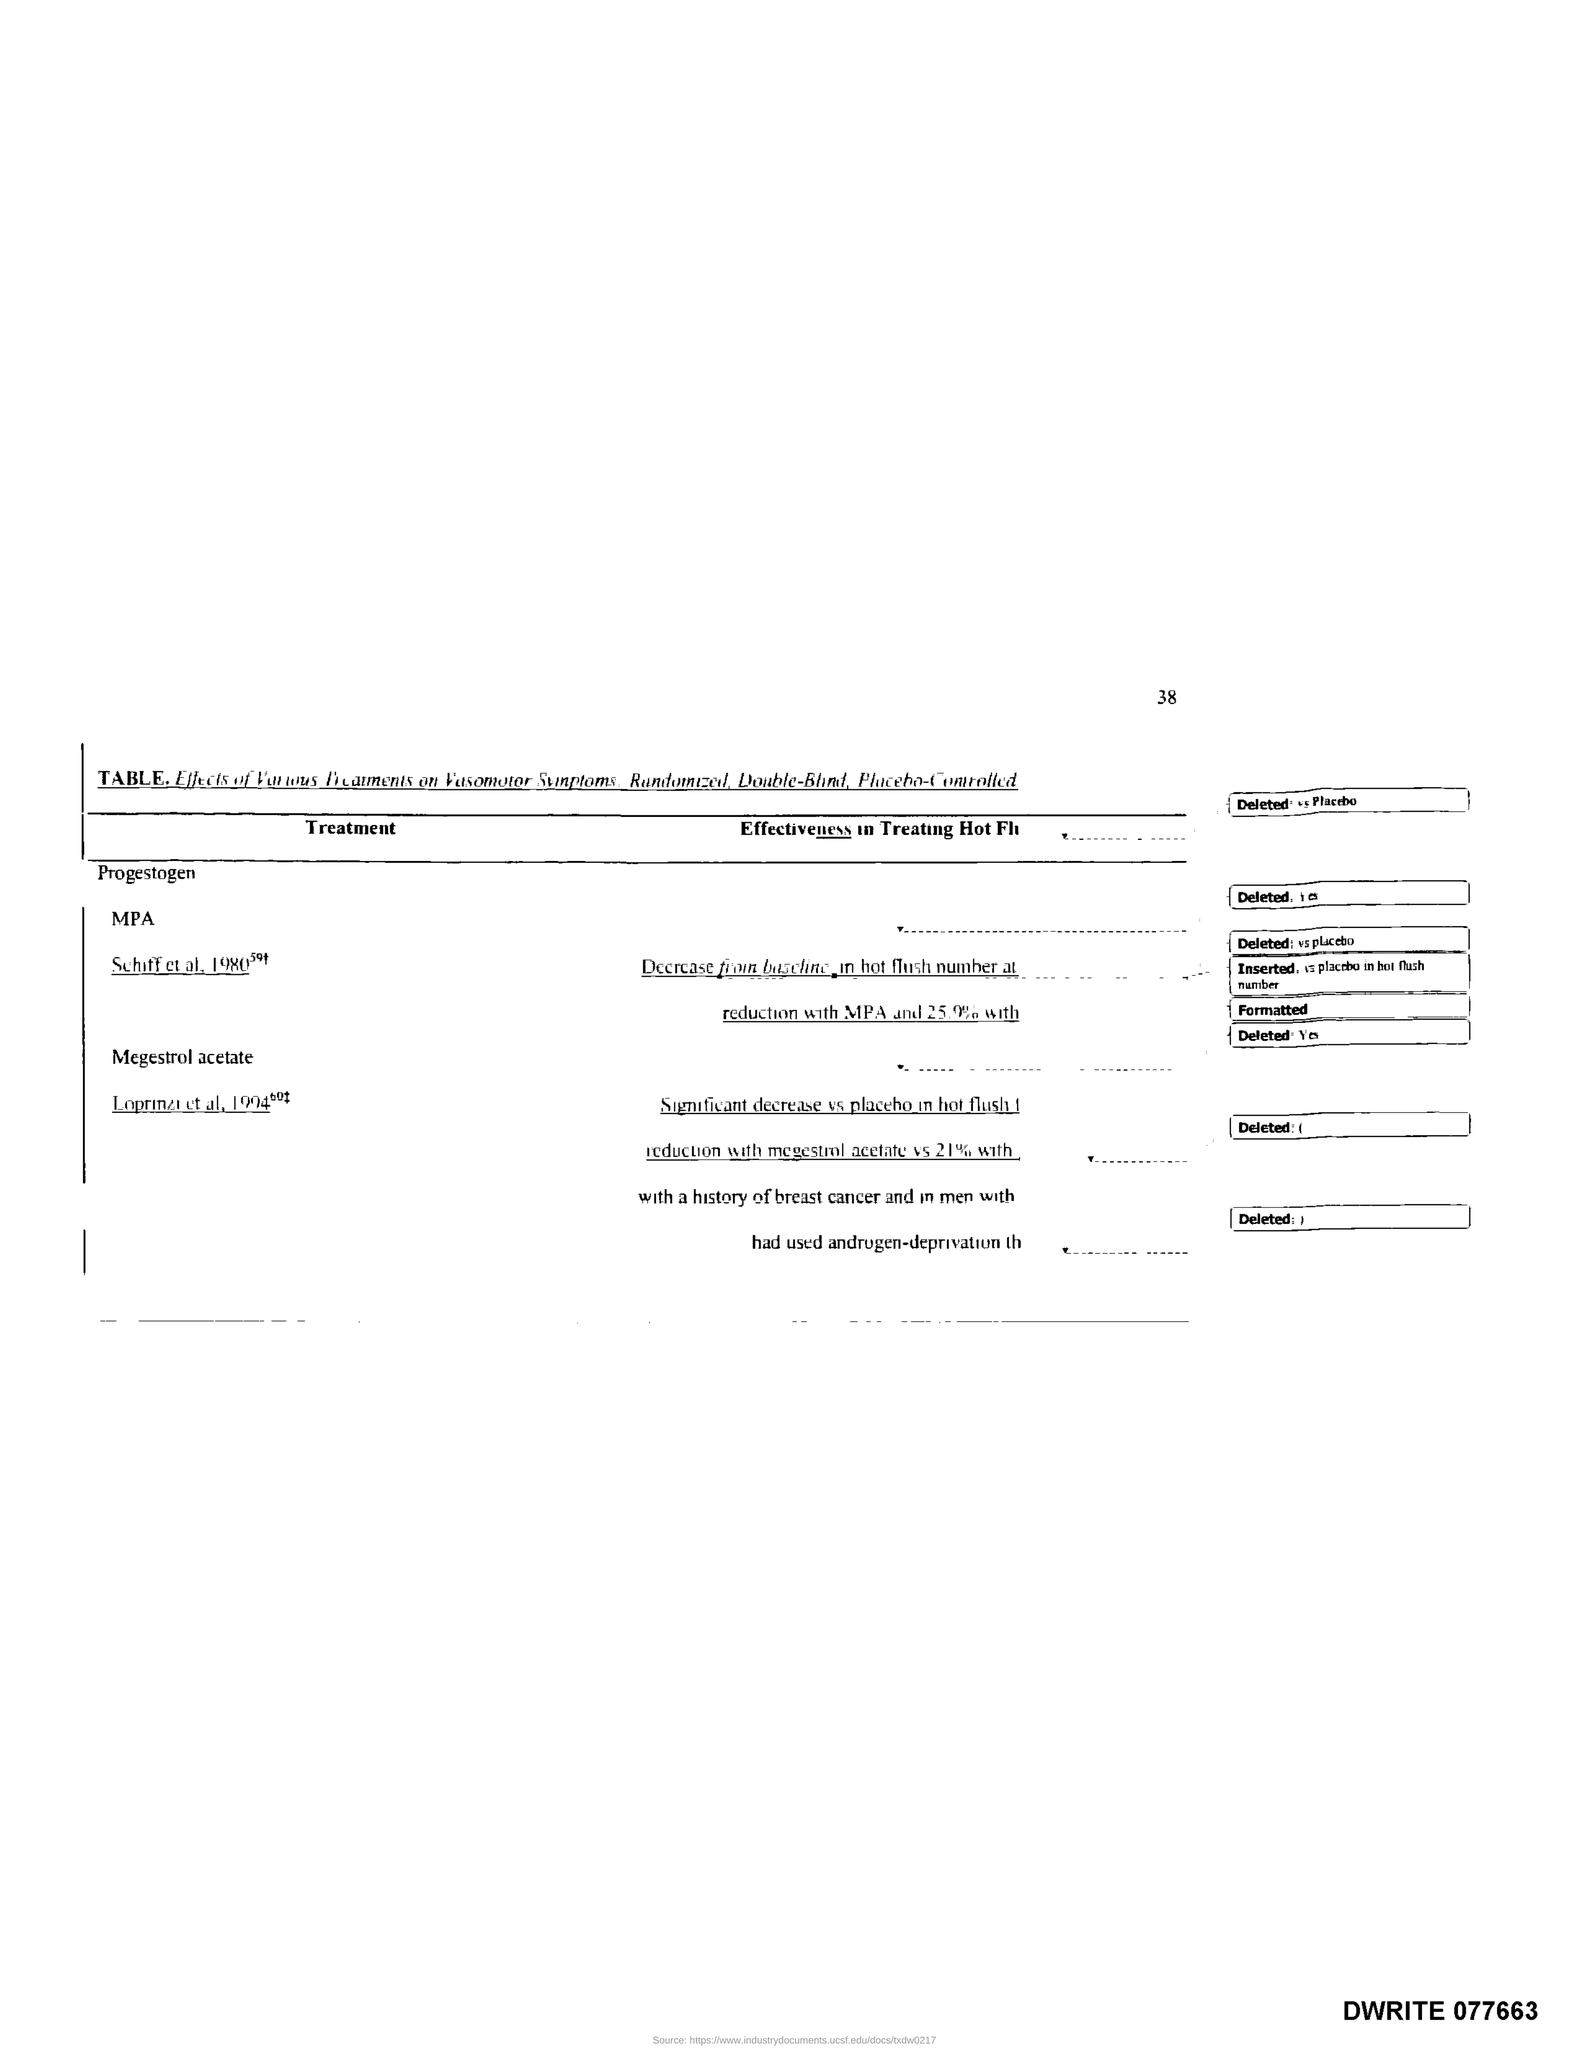Draw attention to some important aspects in this diagram. The page number is 38. 